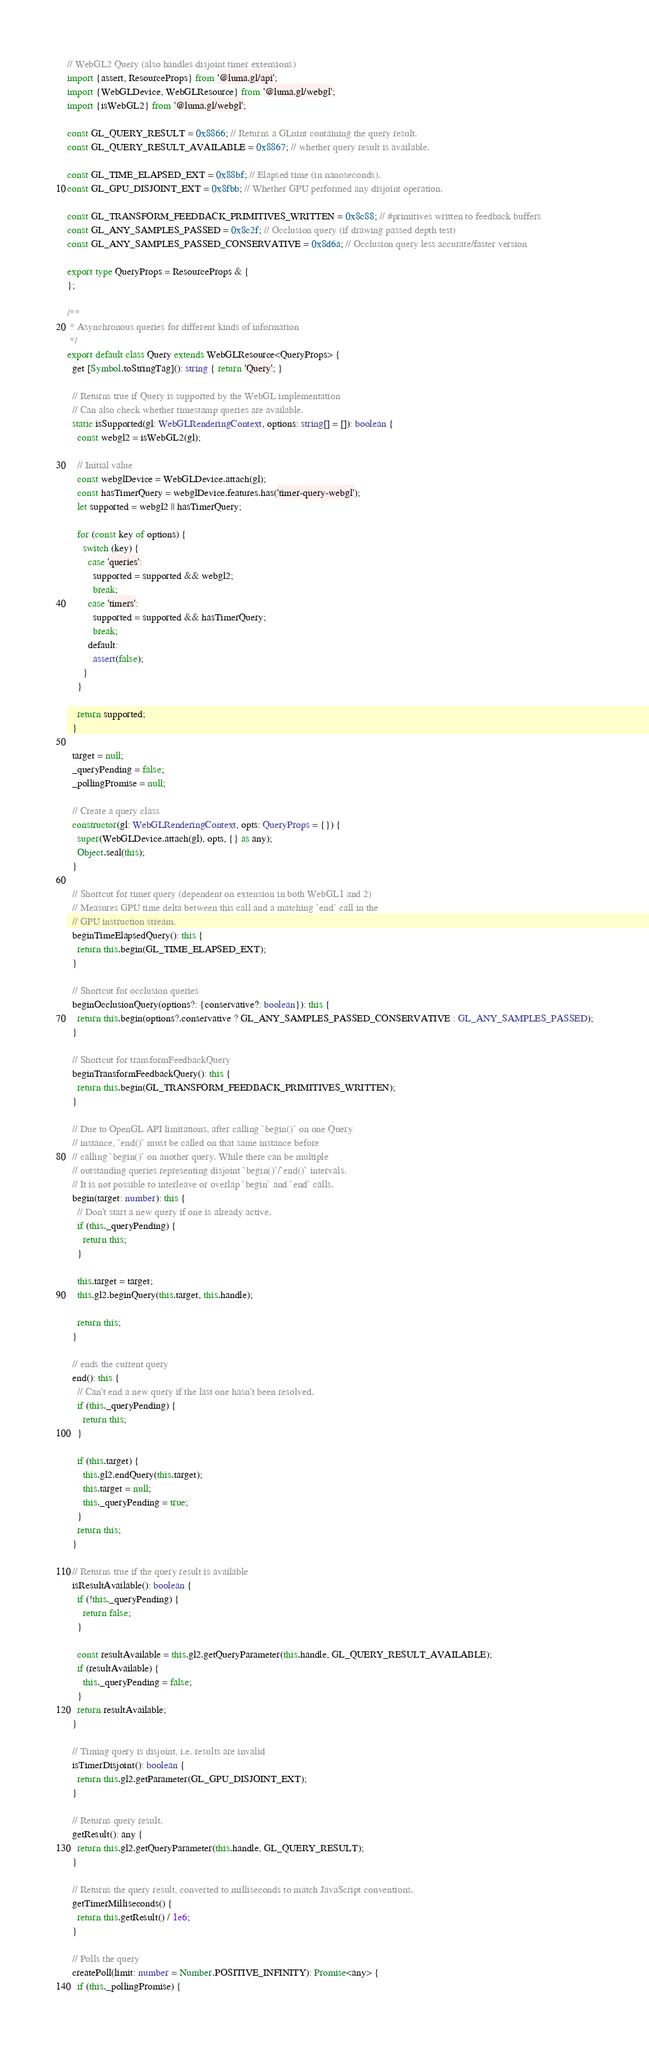Convert code to text. <code><loc_0><loc_0><loc_500><loc_500><_TypeScript_>// WebGL2 Query (also handles disjoint timer extensions)
import {assert, ResourceProps} from '@luma.gl/api';
import {WebGLDevice, WebGLResource} from '@luma.gl/webgl';
import {isWebGL2} from '@luma.gl/webgl';

const GL_QUERY_RESULT = 0x8866; // Returns a GLuint containing the query result.
const GL_QUERY_RESULT_AVAILABLE = 0x8867; // whether query result is available.

const GL_TIME_ELAPSED_EXT = 0x88bf; // Elapsed time (in nanoseconds).
const GL_GPU_DISJOINT_EXT = 0x8fbb; // Whether GPU performed any disjoint operation.

const GL_TRANSFORM_FEEDBACK_PRIMITIVES_WRITTEN = 0x8c88; // #primitives written to feedback buffers
const GL_ANY_SAMPLES_PASSED = 0x8c2f; // Occlusion query (if drawing passed depth test)
const GL_ANY_SAMPLES_PASSED_CONSERVATIVE = 0x8d6a; // Occlusion query less accurate/faster version

export type QueryProps = ResourceProps & {
};

/**
 * Asynchronous queries for different kinds of information
 */
export default class Query extends WebGLResource<QueryProps> {
  get [Symbol.toStringTag](): string { return 'Query'; }

  // Returns true if Query is supported by the WebGL implementation
  // Can also check whether timestamp queries are available.
  static isSupported(gl: WebGLRenderingContext, options: string[] = []): boolean {
    const webgl2 = isWebGL2(gl);

    // Initial value
    const webglDevice = WebGLDevice.attach(gl);
    const hasTimerQuery = webglDevice.features.has('timer-query-webgl');
    let supported = webgl2 || hasTimerQuery;

    for (const key of options) {
      switch (key) {
        case 'queries':
          supported = supported && webgl2;
          break;
        case 'timers':
          supported = supported && hasTimerQuery;
          break;
        default:
          assert(false);
      }
    }

    return supported;
  }

  target = null;
  _queryPending = false;
  _pollingPromise = null;

  // Create a query class
  constructor(gl: WebGLRenderingContext, opts: QueryProps = {}) {
    super(WebGLDevice.attach(gl), opts, {} as any);
    Object.seal(this);
  }

  // Shortcut for timer query (dependent on extension in both WebGL1 and 2)
  // Measures GPU time delta between this call and a matching `end` call in the
  // GPU instruction stream.
  beginTimeElapsedQuery(): this {
    return this.begin(GL_TIME_ELAPSED_EXT);
  }

  // Shortcut for occlusion queries
  beginOcclusionQuery(options?: {conservative?: boolean}): this {
    return this.begin(options?.conservative ? GL_ANY_SAMPLES_PASSED_CONSERVATIVE : GL_ANY_SAMPLES_PASSED);
  }

  // Shortcut for transformFeedbackQuery
  beginTransformFeedbackQuery(): this {
    return this.begin(GL_TRANSFORM_FEEDBACK_PRIMITIVES_WRITTEN);
  }

  // Due to OpenGL API limitations, after calling `begin()` on one Query
  // instance, `end()` must be called on that same instance before
  // calling `begin()` on another query. While there can be multiple
  // outstanding queries representing disjoint `begin()`/`end()` intervals.
  // It is not possible to interleave or overlap `begin` and `end` calls.
  begin(target: number): this {
    // Don't start a new query if one is already active.
    if (this._queryPending) {
      return this;
    }

    this.target = target;
    this.gl2.beginQuery(this.target, this.handle);

    return this;
  }

  // ends the current query
  end(): this {
    // Can't end a new query if the last one hasn't been resolved.
    if (this._queryPending) {
      return this;
    }

    if (this.target) {
      this.gl2.endQuery(this.target);
      this.target = null;
      this._queryPending = true;
    }
    return this;
  }

  // Returns true if the query result is available
  isResultAvailable(): boolean {
    if (!this._queryPending) {
      return false;
    }

    const resultAvailable = this.gl2.getQueryParameter(this.handle, GL_QUERY_RESULT_AVAILABLE);
    if (resultAvailable) {
      this._queryPending = false;
    }
    return resultAvailable;
  }

  // Timing query is disjoint, i.e. results are invalid
  isTimerDisjoint(): boolean {
    return this.gl2.getParameter(GL_GPU_DISJOINT_EXT);
  }

  // Returns query result.
  getResult(): any {
    return this.gl2.getQueryParameter(this.handle, GL_QUERY_RESULT);
  }

  // Returns the query result, converted to milliseconds to match JavaScript conventions.
  getTimerMilliseconds() {
    return this.getResult() / 1e6;
  }

  // Polls the query
  createPoll(limit: number = Number.POSITIVE_INFINITY): Promise<any> {
    if (this._pollingPromise) {</code> 